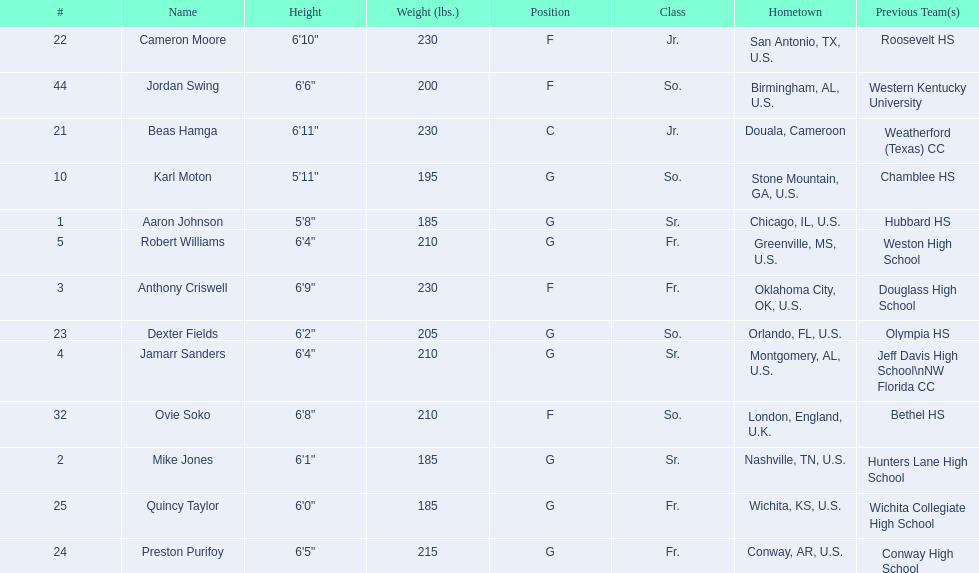Other than soko, who are the players? Aaron Johnson, Anthony Criswell, Jamarr Sanders, Robert Williams, Karl Moton, Beas Hamga, Cameron Moore, Dexter Fields, Preston Purifoy, Mike Jones, Quincy Taylor, Jordan Swing. Of those players, who is a player that is not from the us? Beas Hamga. 